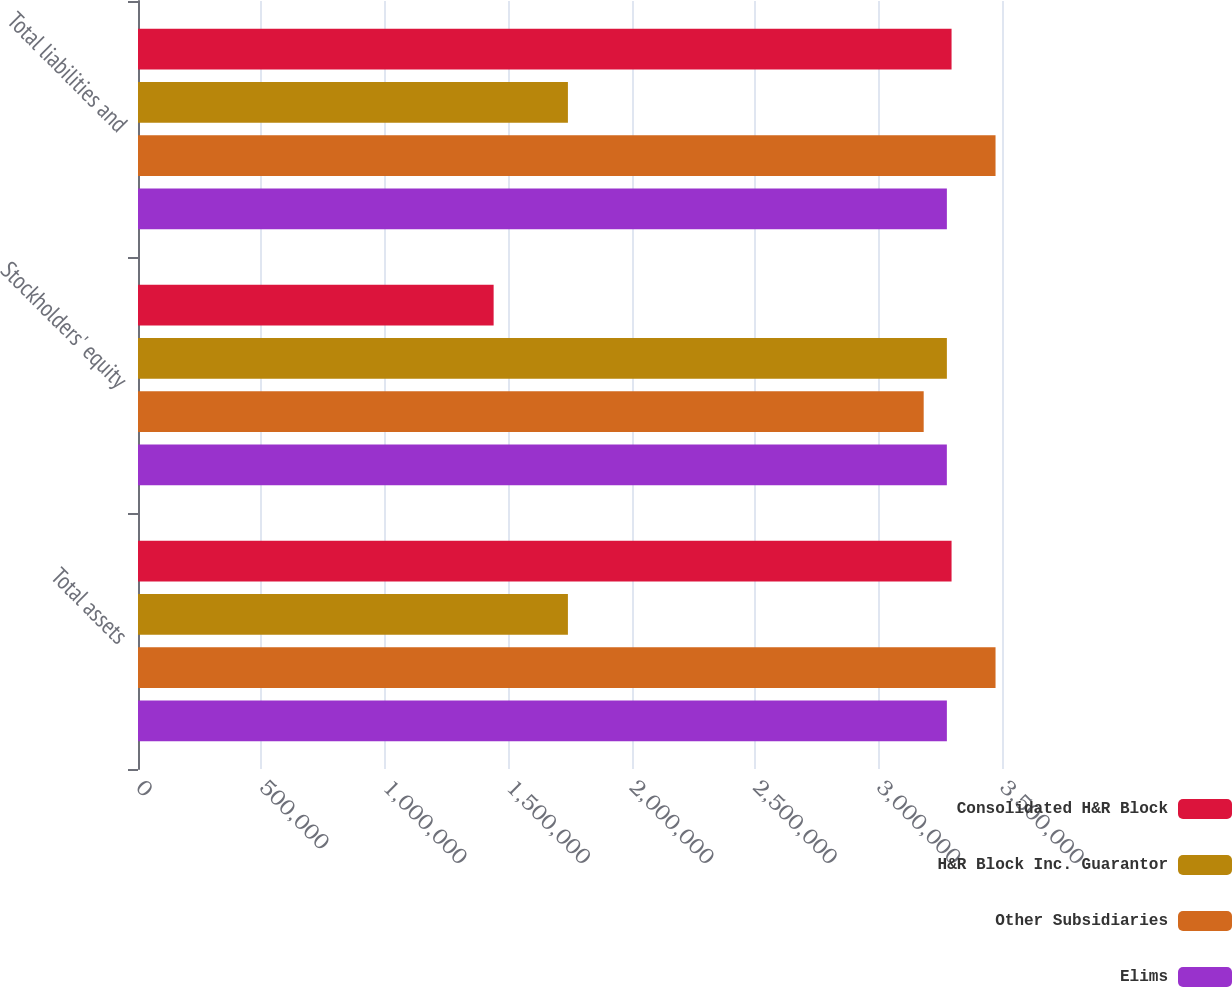<chart> <loc_0><loc_0><loc_500><loc_500><stacked_bar_chart><ecel><fcel>Total assets<fcel>Stockholders' equity<fcel>Total liabilities and<nl><fcel>Consolidated H&R Block<fcel>3.29567e+06<fcel>1.44063e+06<fcel>3.29567e+06<nl><fcel>H&R Block Inc. Guarantor<fcel>1.74156e+06<fcel>3.27671e+06<fcel>1.74156e+06<nl><fcel>Other Subsidiaries<fcel>3.4738e+06<fcel>3.18277e+06<fcel>3.4738e+06<nl><fcel>Elims<fcel>3.27671e+06<fcel>3.2766e+06<fcel>3.27671e+06<nl></chart> 